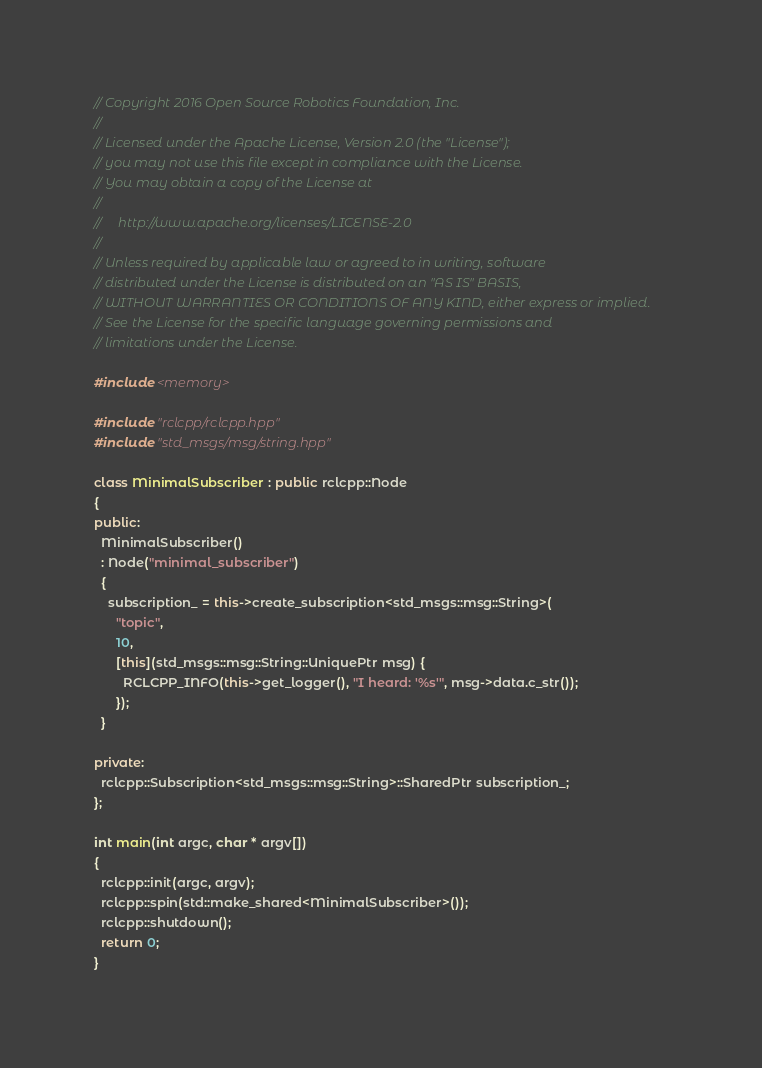Convert code to text. <code><loc_0><loc_0><loc_500><loc_500><_C++_>// Copyright 2016 Open Source Robotics Foundation, Inc.
//
// Licensed under the Apache License, Version 2.0 (the "License");
// you may not use this file except in compliance with the License.
// You may obtain a copy of the License at
//
//     http://www.apache.org/licenses/LICENSE-2.0
//
// Unless required by applicable law or agreed to in writing, software
// distributed under the License is distributed on an "AS IS" BASIS,
// WITHOUT WARRANTIES OR CONDITIONS OF ANY KIND, either express or implied.
// See the License for the specific language governing permissions and
// limitations under the License.

#include <memory>

#include "rclcpp/rclcpp.hpp"
#include "std_msgs/msg/string.hpp"

class MinimalSubscriber : public rclcpp::Node
{
public:
  MinimalSubscriber()
  : Node("minimal_subscriber")
  {
    subscription_ = this->create_subscription<std_msgs::msg::String>(
      "topic",
      10,
      [this](std_msgs::msg::String::UniquePtr msg) {
        RCLCPP_INFO(this->get_logger(), "I heard: '%s'", msg->data.c_str());
      });
  }

private:
  rclcpp::Subscription<std_msgs::msg::String>::SharedPtr subscription_;
};

int main(int argc, char * argv[])
{
  rclcpp::init(argc, argv);
  rclcpp::spin(std::make_shared<MinimalSubscriber>());
  rclcpp::shutdown();
  return 0;
}
</code> 